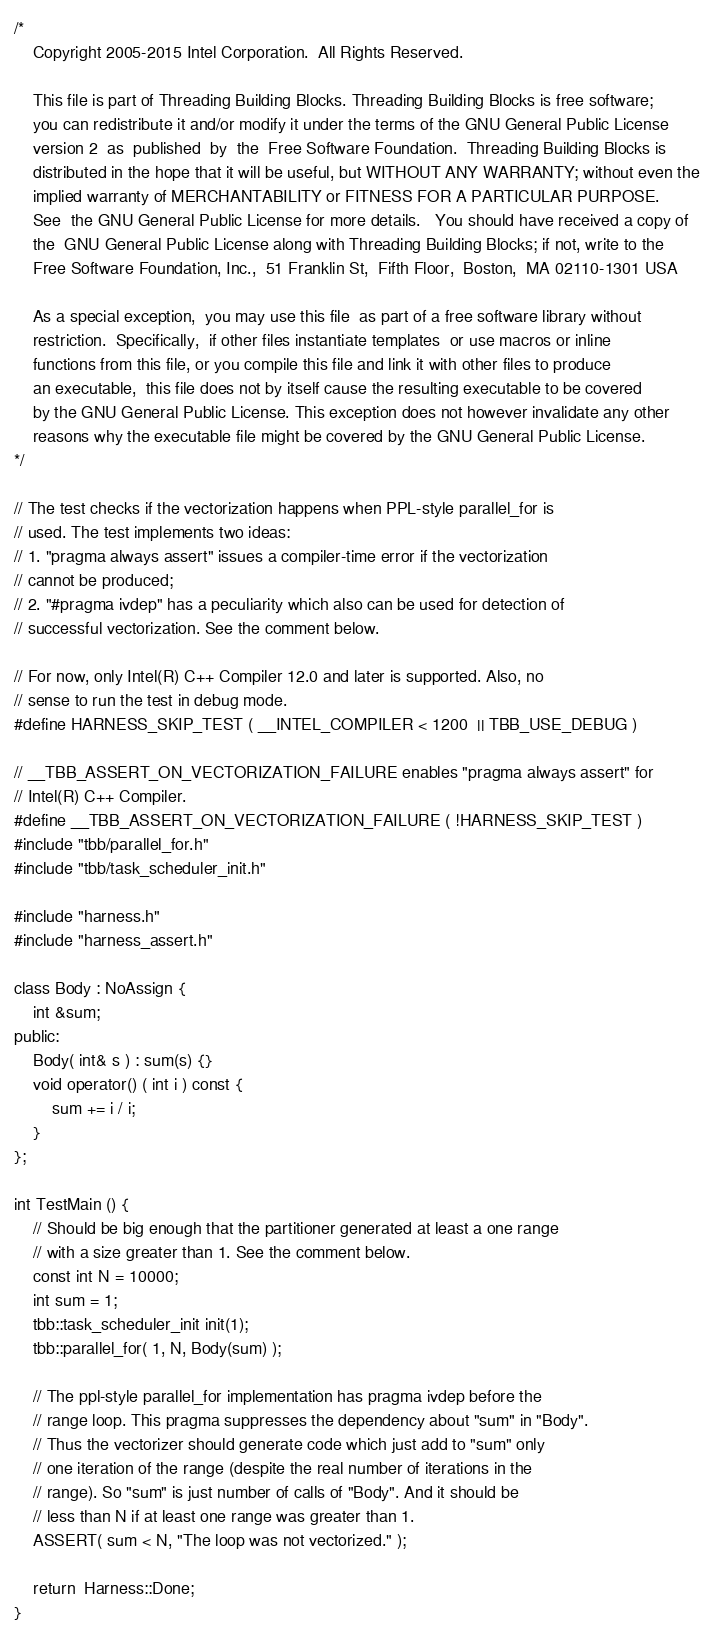Convert code to text. <code><loc_0><loc_0><loc_500><loc_500><_C++_>/*
    Copyright 2005-2015 Intel Corporation.  All Rights Reserved.

    This file is part of Threading Building Blocks. Threading Building Blocks is free software;
    you can redistribute it and/or modify it under the terms of the GNU General Public License
    version 2  as  published  by  the  Free Software Foundation.  Threading Building Blocks is
    distributed in the hope that it will be useful, but WITHOUT ANY WARRANTY; without even the
    implied warranty of MERCHANTABILITY or FITNESS FOR A PARTICULAR PURPOSE.
    See  the GNU General Public License for more details.   You should have received a copy of
    the  GNU General Public License along with Threading Building Blocks; if not, write to the
    Free Software Foundation, Inc.,  51 Franklin St,  Fifth Floor,  Boston,  MA 02110-1301 USA

    As a special exception,  you may use this file  as part of a free software library without
    restriction.  Specifically,  if other files instantiate templates  or use macros or inline
    functions from this file, or you compile this file and link it with other files to produce
    an executable,  this file does not by itself cause the resulting executable to be covered
    by the GNU General Public License. This exception does not however invalidate any other
    reasons why the executable file might be covered by the GNU General Public License.
*/

// The test checks if the vectorization happens when PPL-style parallel_for is
// used. The test implements two ideas:
// 1. "pragma always assert" issues a compiler-time error if the vectorization
// cannot be produced;
// 2. "#pragma ivdep" has a peculiarity which also can be used for detection of
// successful vectorization. See the comment below.

// For now, only Intel(R) C++ Compiler 12.0 and later is supported. Also, no
// sense to run the test in debug mode.
#define HARNESS_SKIP_TEST ( __INTEL_COMPILER < 1200  || TBB_USE_DEBUG )

// __TBB_ASSERT_ON_VECTORIZATION_FAILURE enables "pragma always assert" for
// Intel(R) C++ Compiler.
#define __TBB_ASSERT_ON_VECTORIZATION_FAILURE ( !HARNESS_SKIP_TEST )
#include "tbb/parallel_for.h"
#include "tbb/task_scheduler_init.h"

#include "harness.h"
#include "harness_assert.h"

class Body : NoAssign {
    int &sum;
public:
    Body( int& s ) : sum(s) {}
    void operator() ( int i ) const {
        sum += i / i;
    }
};

int TestMain () {
    // Should be big enough that the partitioner generated at least a one range
    // with a size greater than 1. See the comment below.
    const int N = 10000;
    int sum = 1;
    tbb::task_scheduler_init init(1);
    tbb::parallel_for( 1, N, Body(sum) );

    // The ppl-style parallel_for implementation has pragma ivdep before the
    // range loop. This pragma suppresses the dependency about "sum" in "Body".
    // Thus the vectorizer should generate code which just add to "sum" only
    // one iteration of the range (despite the real number of iterations in the
    // range). So "sum" is just number of calls of "Body". And it should be
    // less than N if at least one range was greater than 1.
    ASSERT( sum < N, "The loop was not vectorized." );

    return  Harness::Done;
}
</code> 